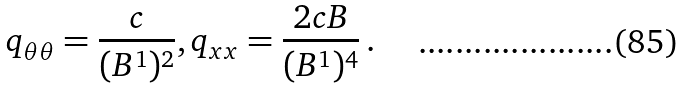<formula> <loc_0><loc_0><loc_500><loc_500>q _ { \theta \theta } = \frac { c } { ( B ^ { 1 } ) ^ { 2 } } , q _ { x x } = \frac { 2 c B } { ( B ^ { 1 } ) ^ { 4 } } \, .</formula> 